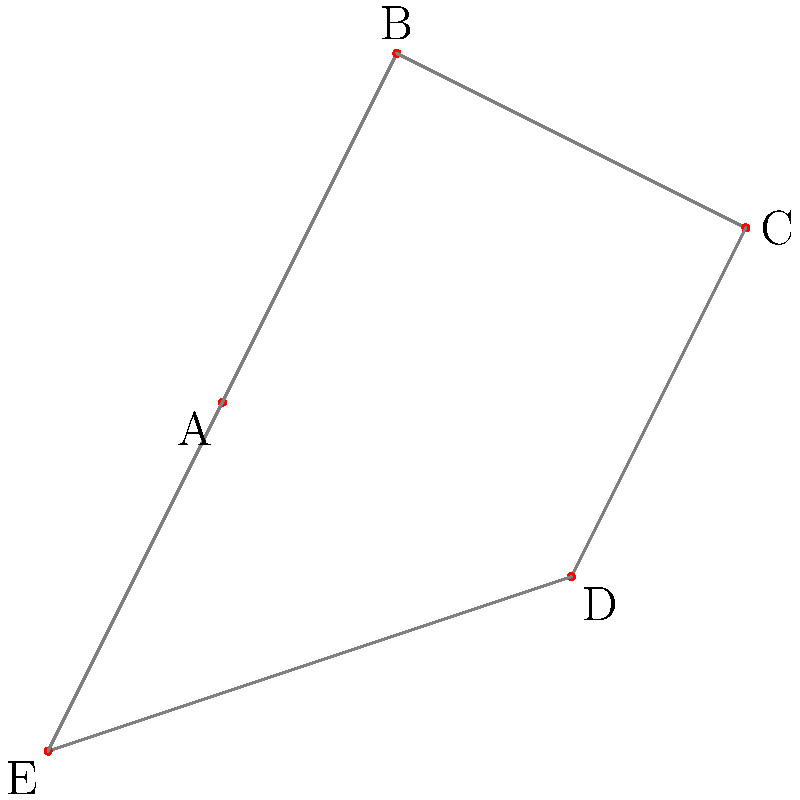Which iconic fashion silhouette does this constellation resemble, and how might it have influenced Karl Lagerfeld's designs for Chanel's Métiers d'Art collections? To answer this question, let's analyze the constellation pattern step-by-step:

1. The connect-the-dots pattern forms a pentagonal shape with five distinct points (A, B, C, D, and E).

2. The shape resembles a stylized flower or star, which is reminiscent of the iconic Chanel camellia flower.

3. The camellia flower has been a signature motif for Chanel since Gabrielle "Coco" Chanel first incorporated it into her designs in the 1920s.

4. Karl Lagerfeld, as the creative director of Chanel from 1983 to 2019, often reimagined and reinterpreted classic Chanel motifs in his collections.

5. The Métiers d'Art collections, in particular, showcase the craftsmanship of Chanel's specialized ateliers and often draw inspiration from various cultural and artistic sources.

6. Lagerfeld might have been inspired by celestial patterns like this constellation to create intricate embroideries, sequin work, or even the overall silhouette of garments in the Métiers d'Art collections.

7. The star-like shape could be translated into a structured peplum jacket, a layered skirt, or even a detailed accessory like a brooch or hair ornament.

8. The connection between fashion and astronomy is not uncommon, as designers often look to the cosmos for inspiration in creating ethereal, otherworldly collections.

Given the persona of a fashion insider who knows Karl Lagerfeld personally, the answer would reflect an understanding of how Lagerfeld's creative process incorporated various inspirations into Chanel's iconic designs.
Answer: Chanel camellia; inspired celestial embroideries and star-shaped silhouettes in Métiers d'Art collections 